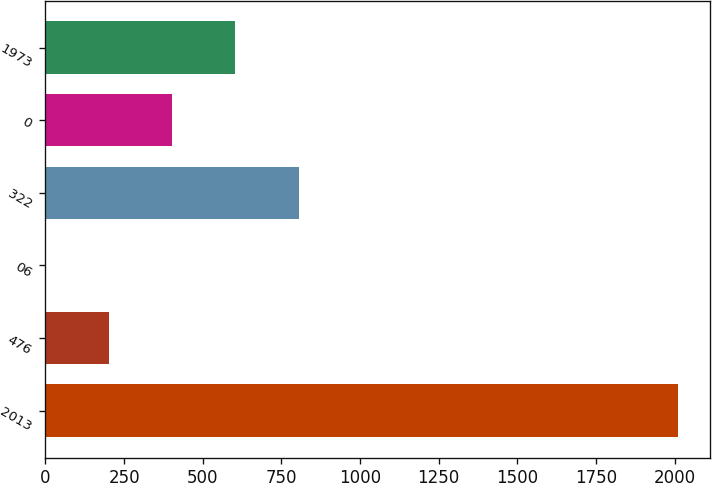Convert chart to OTSL. <chart><loc_0><loc_0><loc_500><loc_500><bar_chart><fcel>2013<fcel>476<fcel>06<fcel>322<fcel>0<fcel>1973<nl><fcel>2011<fcel>201.19<fcel>0.1<fcel>804.46<fcel>402.28<fcel>603.37<nl></chart> 